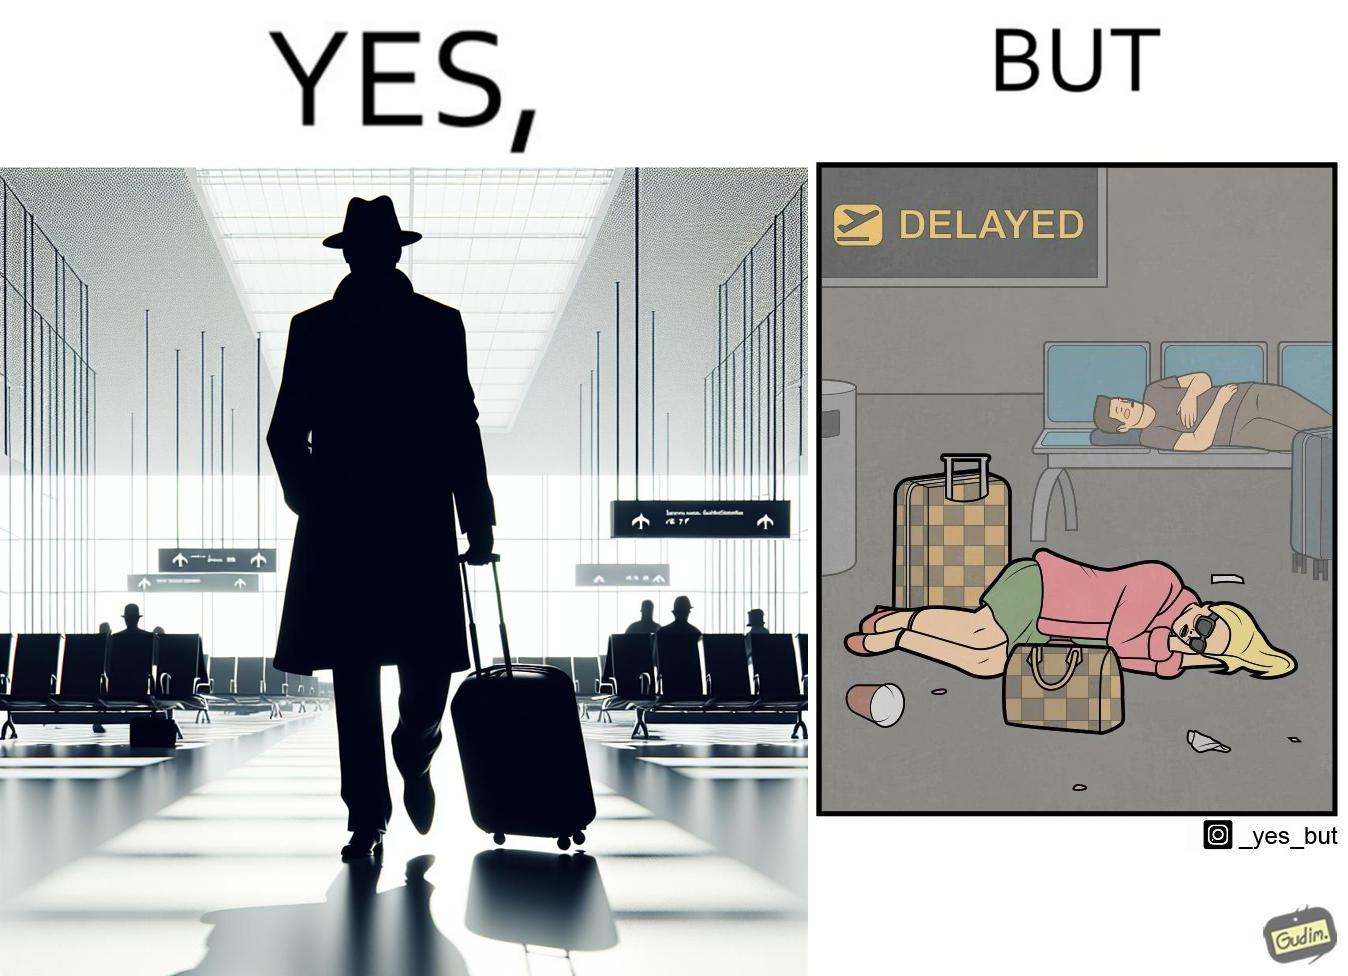Compare the left and right sides of this image. In the left part of the image: an apparently rich person walking inside the airport with luggage. In the right part of the image: a person sleeping on the floor of an airport with luggage due to a delayed flight and absence of vacant seats in the airport. 